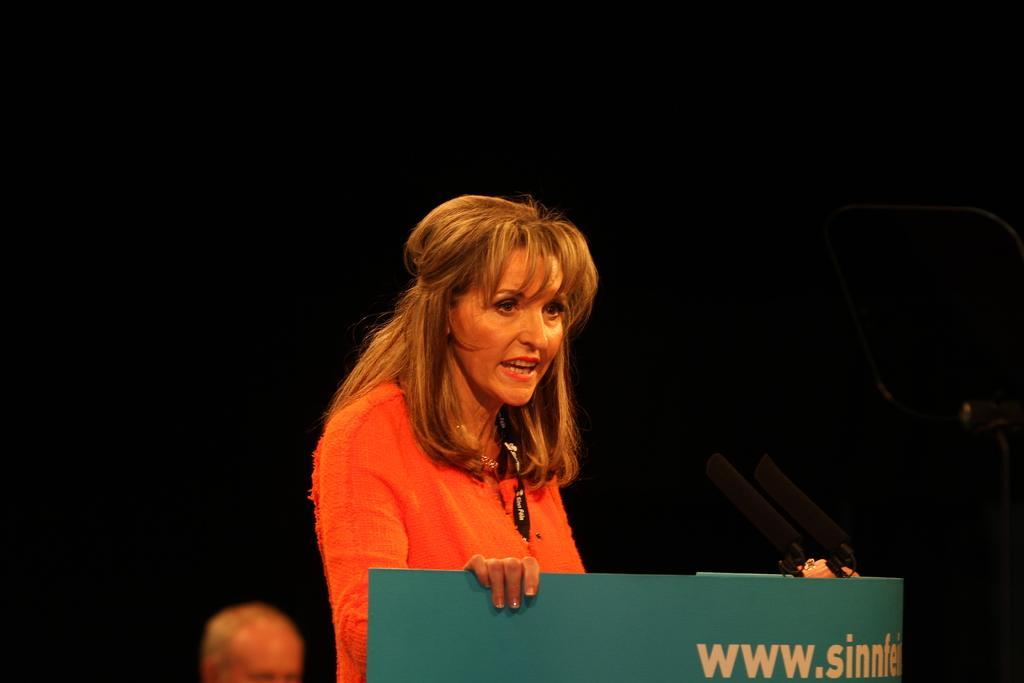Please provide a concise description of this image. In the foreground I can see two persons in front of a table and mike's. The background is dark in color. This image is taken may be on the stage. 